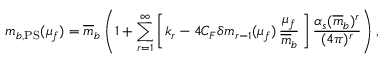Convert formula to latex. <formula><loc_0><loc_0><loc_500><loc_500>m _ { b , P S } ( \mu _ { f } ) = \overline { m } _ { b } \left ( 1 + \sum _ { r = 1 } ^ { \infty } \left [ k _ { r } - 4 C _ { F } \delta m _ { r - 1 } ( \mu _ { f } ) \, \frac { \mu _ { f } } { \overline { m } _ { b } } \, \right ] \, \frac { \alpha _ { s } ( \overline { m } _ { b } ) ^ { r } } { ( 4 \pi ) ^ { r } } \right ) ,</formula> 